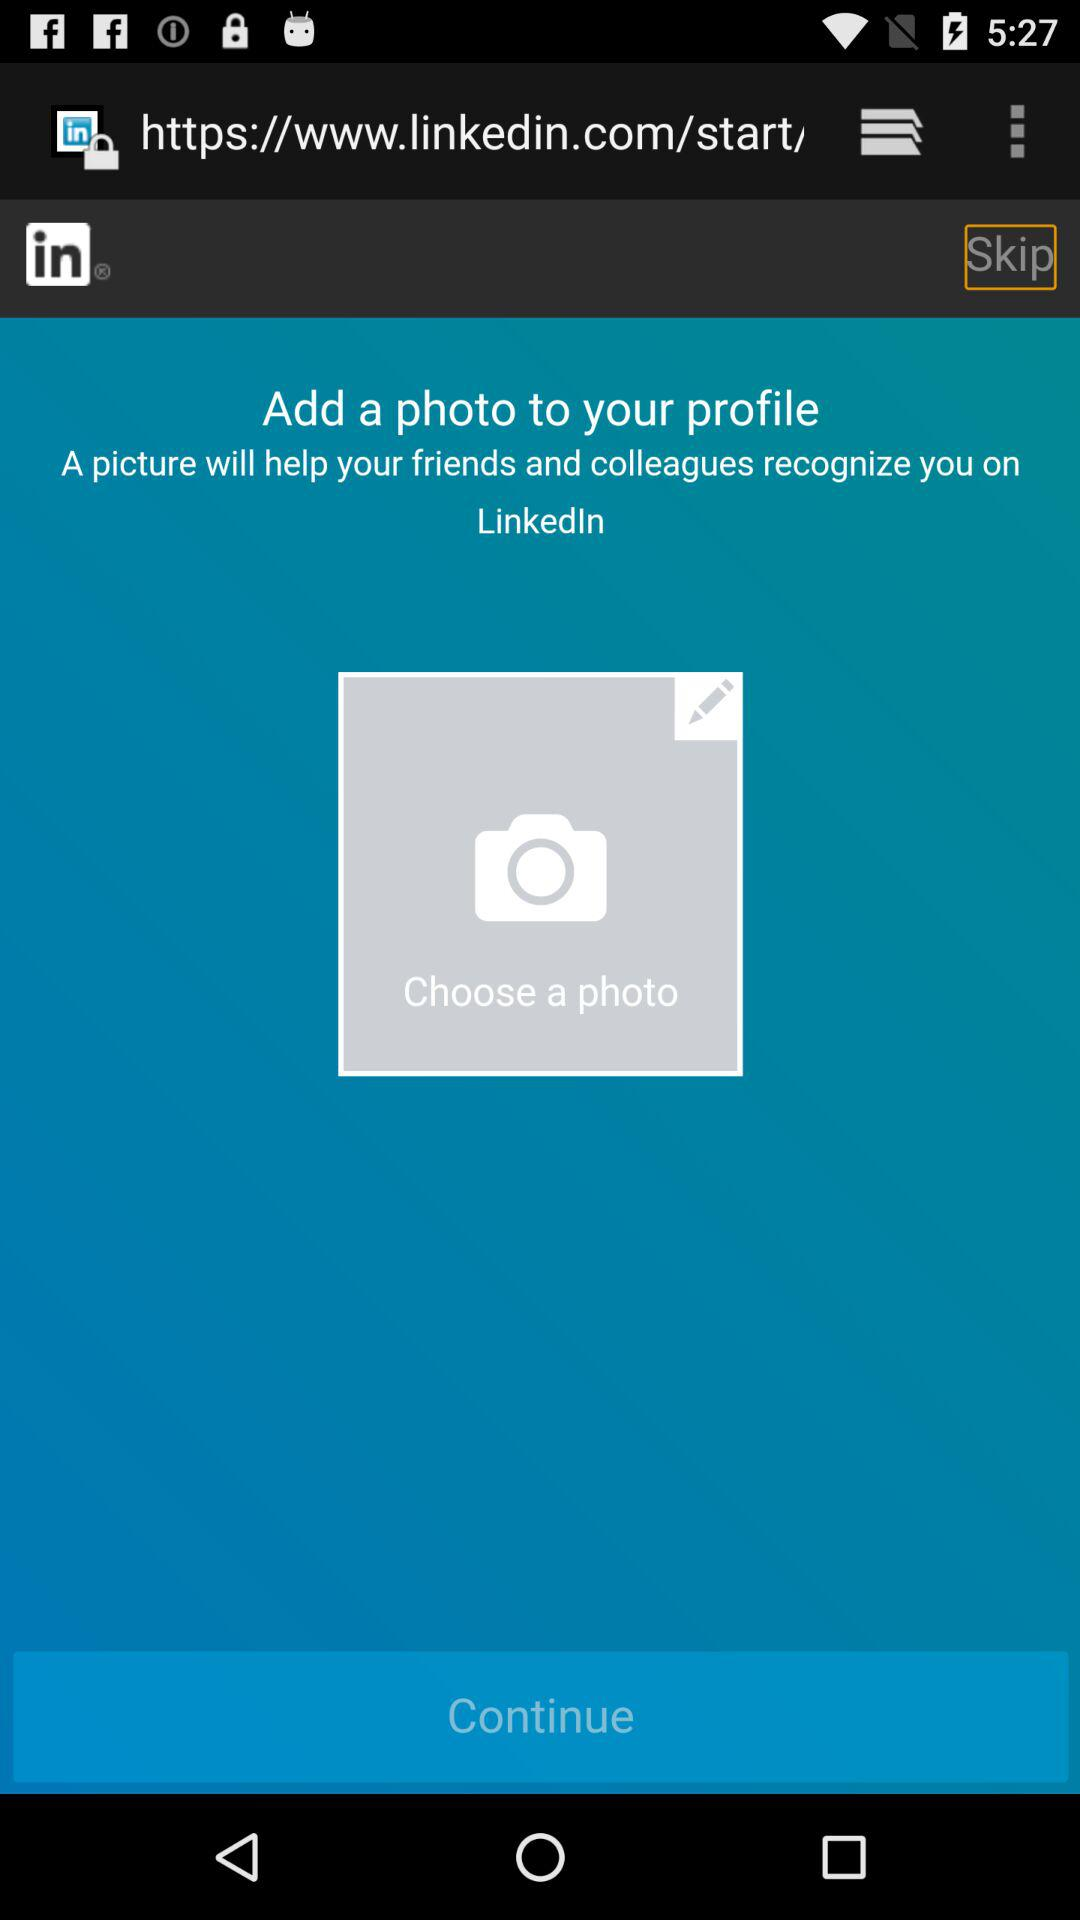What do I need to add so that my friends and colleagues can recognize me on LinkedIn? You need to add a picture so that your friends and colleagues can recognize you on LinkedIn. 